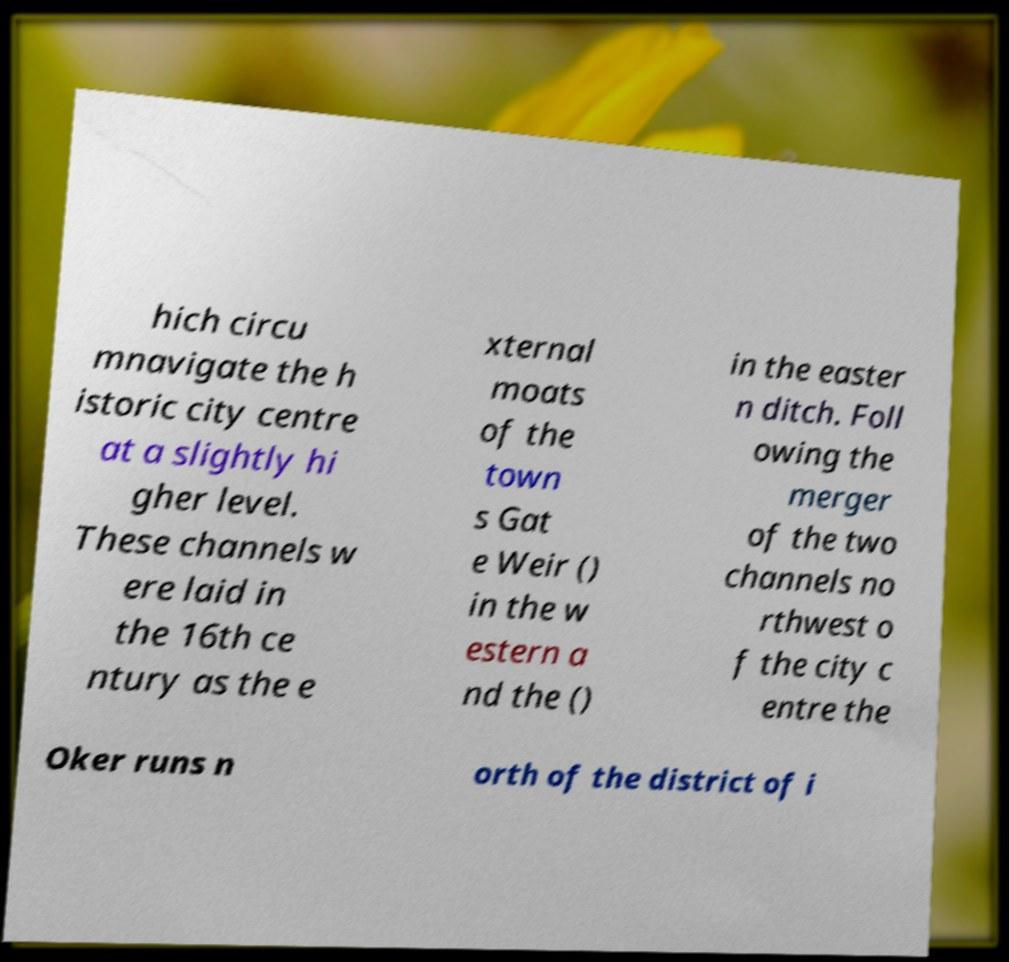Could you assist in decoding the text presented in this image and type it out clearly? hich circu mnavigate the h istoric city centre at a slightly hi gher level. These channels w ere laid in the 16th ce ntury as the e xternal moats of the town s Gat e Weir () in the w estern a nd the () in the easter n ditch. Foll owing the merger of the two channels no rthwest o f the city c entre the Oker runs n orth of the district of i 